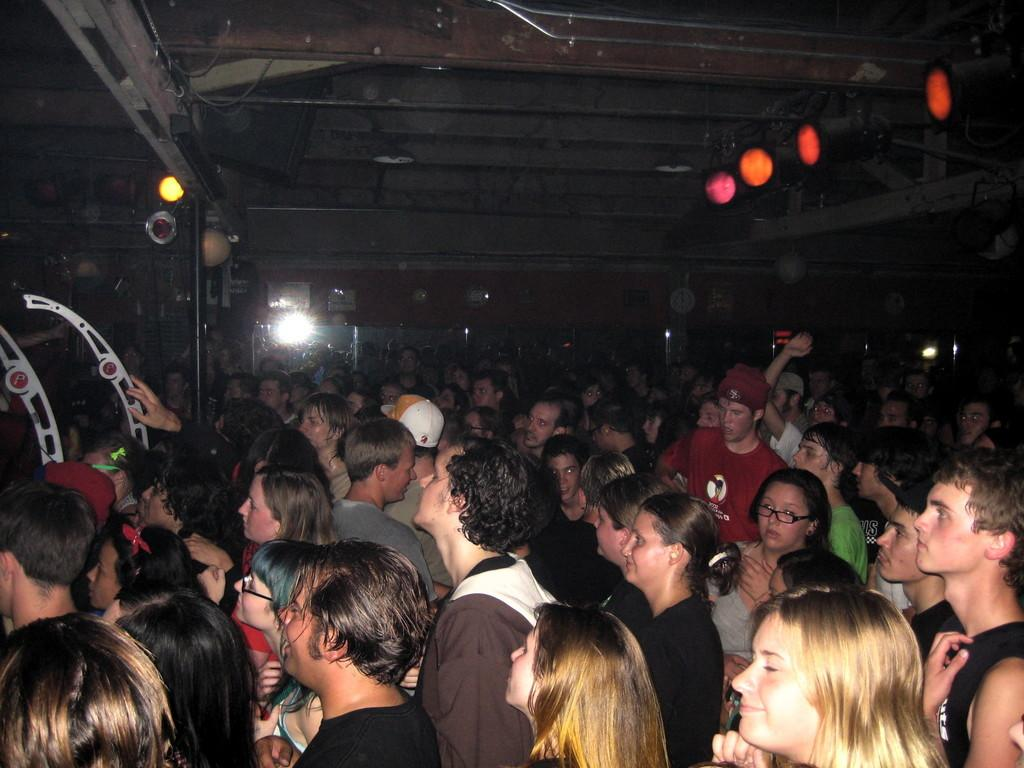How many people are in the image? There is a group of people in the image. What can be seen illuminated in the image? There are lights visible in the image. What object is present in the image that might be used for support or display? There is a pole in the image. What is the color of the background in the image? The background of the image is dark. What time-related object is visible in the background of the image? There is a clock in the background of the image. What type of structure is visible in the background of the image? There is a wall in the background of the image. What type of boot is being used to pave the road in the image? There is no boot or road present in the image; it features a group of people, lights, a pole, and a dark background with a clock and a wall. 